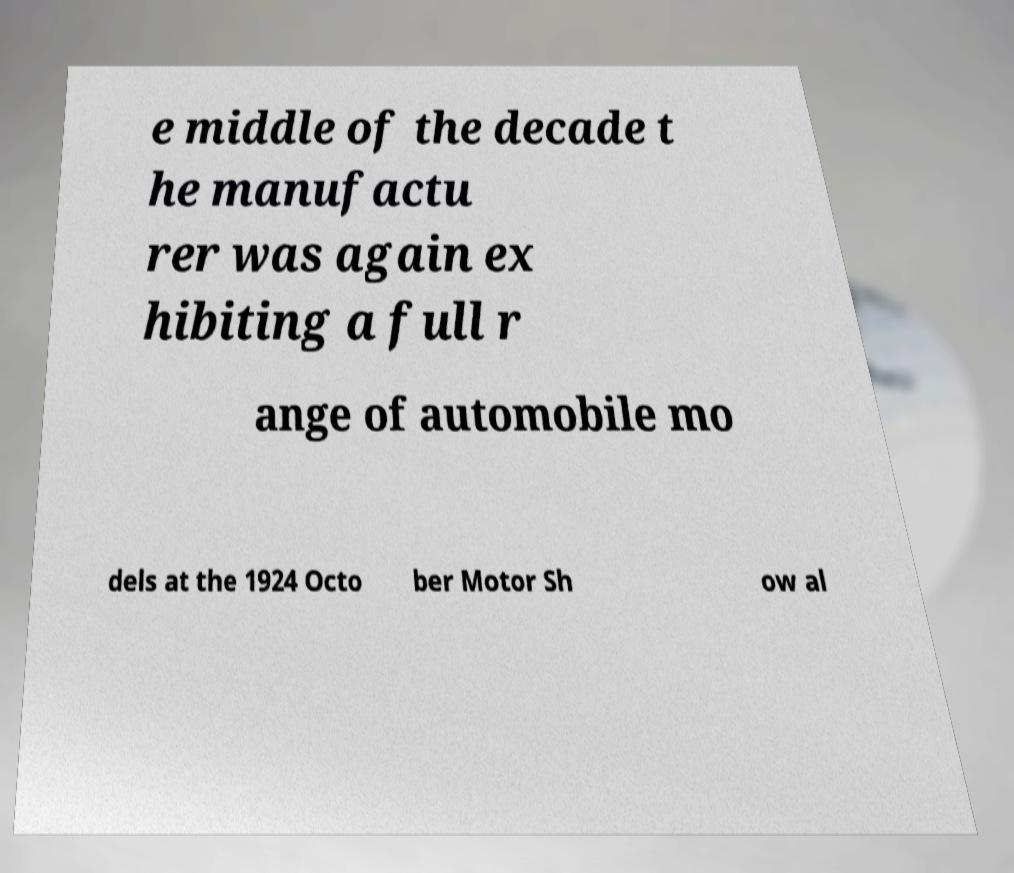Could you assist in decoding the text presented in this image and type it out clearly? e middle of the decade t he manufactu rer was again ex hibiting a full r ange of automobile mo dels at the 1924 Octo ber Motor Sh ow al 